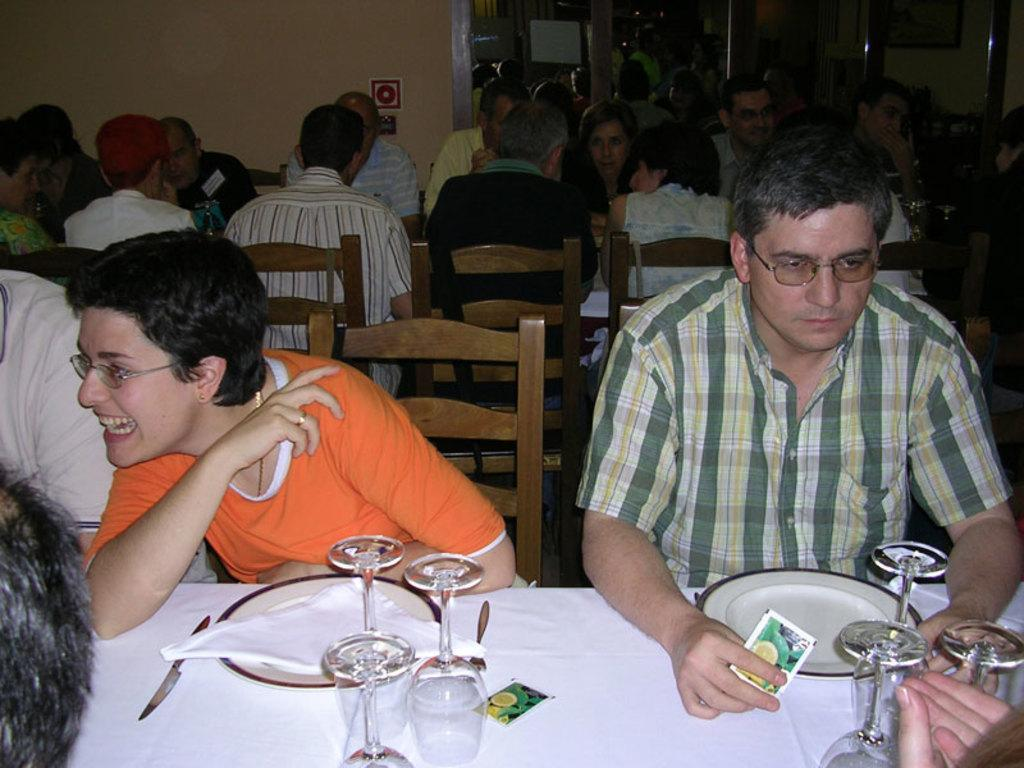What is the main subject of the image? The main subject of the image is a group of people. What are the people doing in the image? The people are seated on chairs in the image. What objects can be seen on the table in the image? There are plates, glasses, forks, and knives on the table in the image. How many beds are visible in the image? There are no beds present in the image. Is there a veil on any of the people in the image? There is no veil visible on any of the people in the image. 